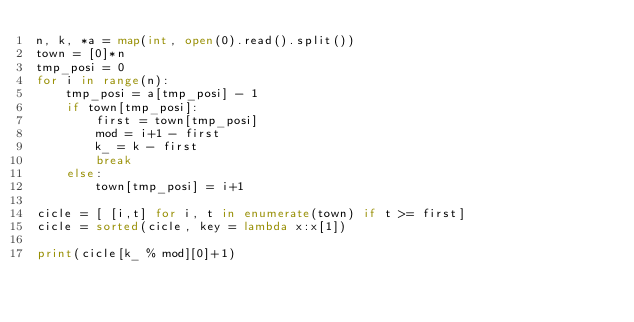Convert code to text. <code><loc_0><loc_0><loc_500><loc_500><_Python_>n, k, *a = map(int, open(0).read().split())
town = [0]*n
tmp_posi = 0
for i in range(n):
    tmp_posi = a[tmp_posi] - 1
    if town[tmp_posi]:
        first = town[tmp_posi]
        mod = i+1 - first
        k_ = k - first
        break
    else:
        town[tmp_posi] = i+1

cicle = [ [i,t] for i, t in enumerate(town) if t >= first]
cicle = sorted(cicle, key = lambda x:x[1])

print(cicle[k_ % mod][0]+1)</code> 